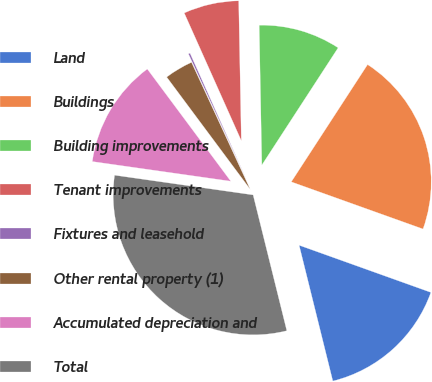<chart> <loc_0><loc_0><loc_500><loc_500><pie_chart><fcel>Land<fcel>Buildings<fcel>Building improvements<fcel>Tenant improvements<fcel>Fixtures and leasehold<fcel>Other rental property (1)<fcel>Accumulated depreciation and<fcel>Total<nl><fcel>15.66%<fcel>21.29%<fcel>9.48%<fcel>6.39%<fcel>0.2%<fcel>3.29%<fcel>12.57%<fcel>31.12%<nl></chart> 